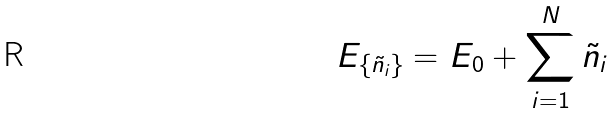Convert formula to latex. <formula><loc_0><loc_0><loc_500><loc_500>E _ { \{ \tilde { n } _ { i } \} } = E _ { 0 } + \sum _ { i = 1 } ^ { N } \tilde { n } _ { i }</formula> 